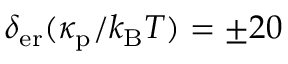<formula> <loc_0><loc_0><loc_500><loc_500>\delta _ { e r } ( \kappa _ { p } / k _ { B } T ) = \pm 2 0</formula> 